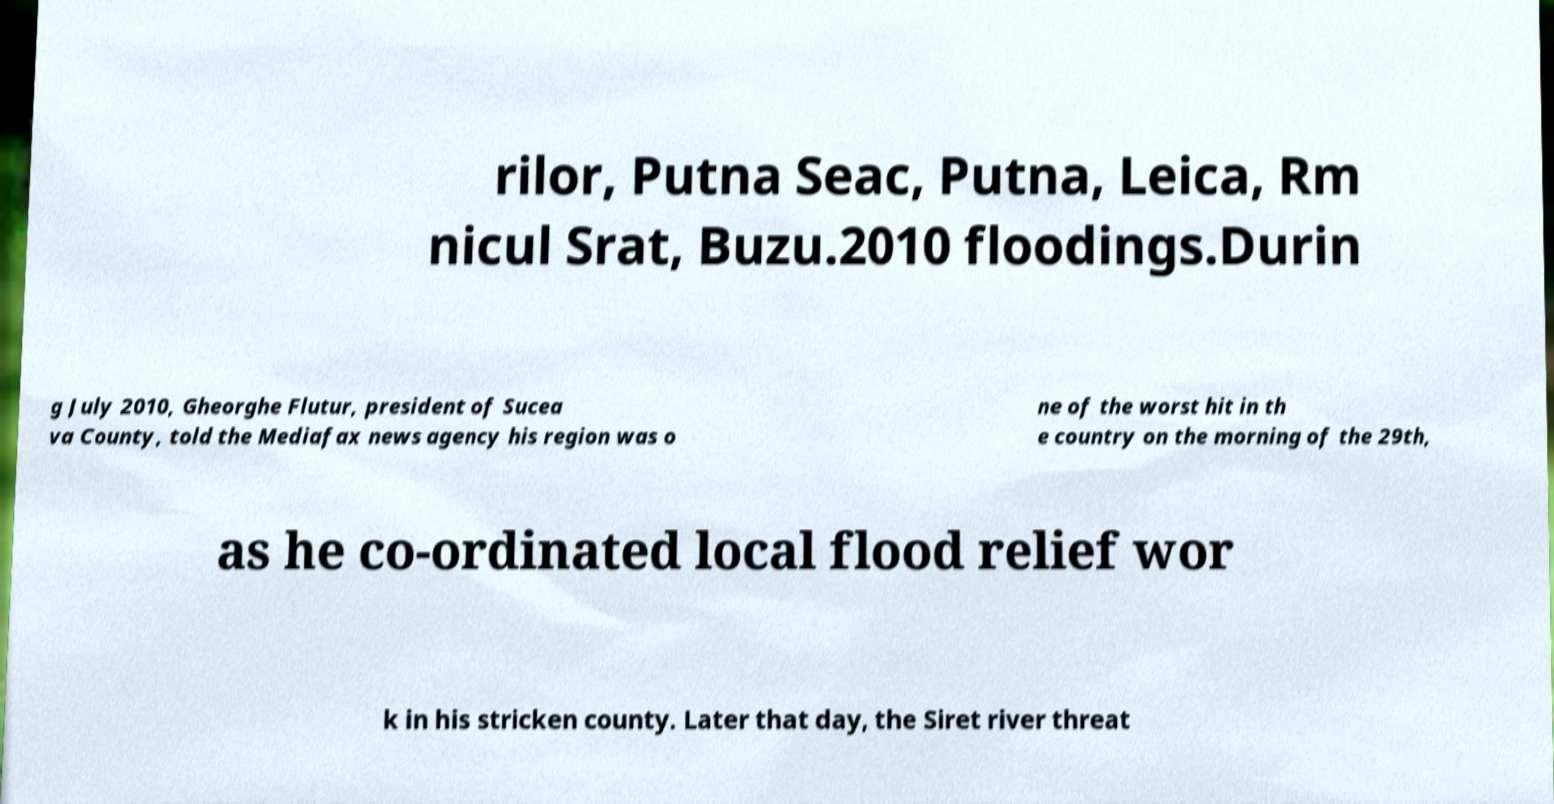Please identify and transcribe the text found in this image. rilor, Putna Seac, Putna, Leica, Rm nicul Srat, Buzu.2010 floodings.Durin g July 2010, Gheorghe Flutur, president of Sucea va County, told the Mediafax news agency his region was o ne of the worst hit in th e country on the morning of the 29th, as he co-ordinated local flood relief wor k in his stricken county. Later that day, the Siret river threat 